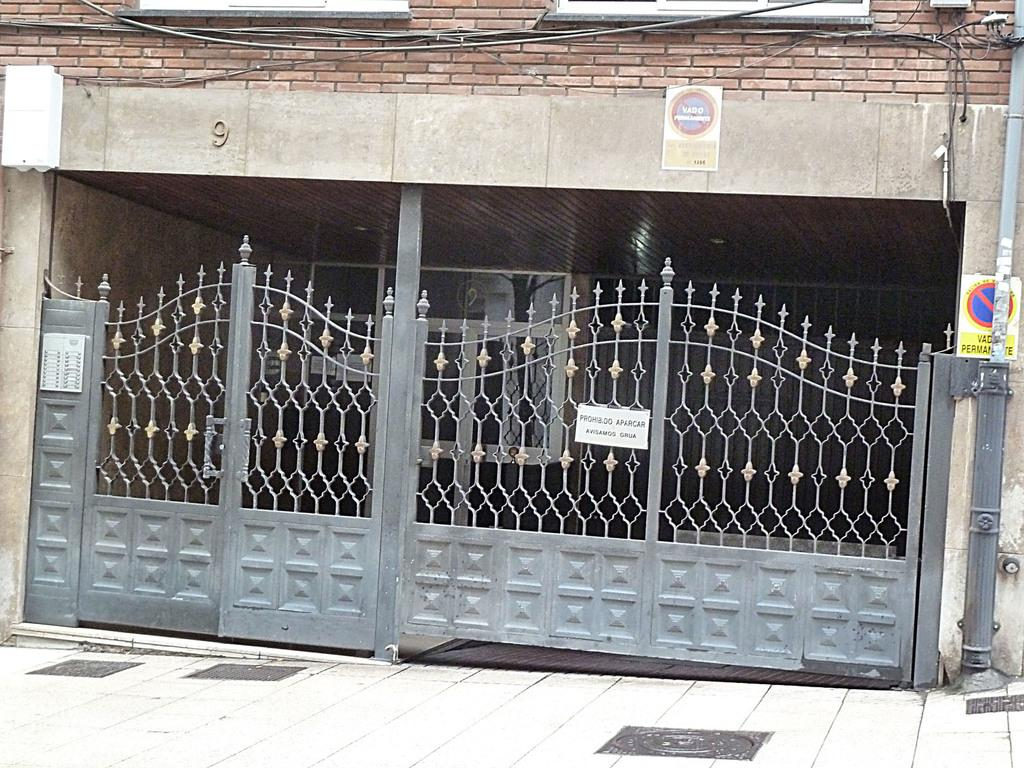What type of structure is visible in the image? There is a building in the image. Is the building in the image located on the moon? No, the image does not depict the building on the moon. The building is likely on Earth, given the lack of any information suggesting otherwise. 